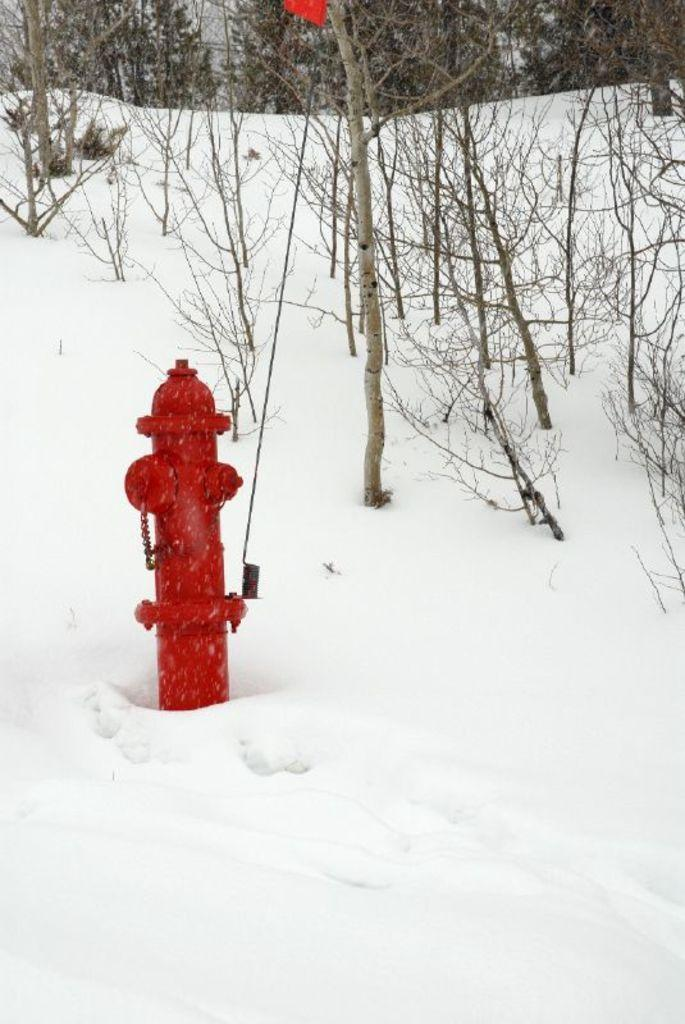What is the color of the hydrant in the image? The hydrant in the image is red. What is the weather condition in the image? There is snow visible in the image, suggesting a cold or wintry condition. What type of vegetation can be seen in the image? There are trees in the image. What type of love advice can be seen written on the hydrant in the image? There is no love advice or any writing present on the hydrant in the image. What type of shade is provided by the trees in the image? There is no mention of shade or any specific detail about the trees in the image. 